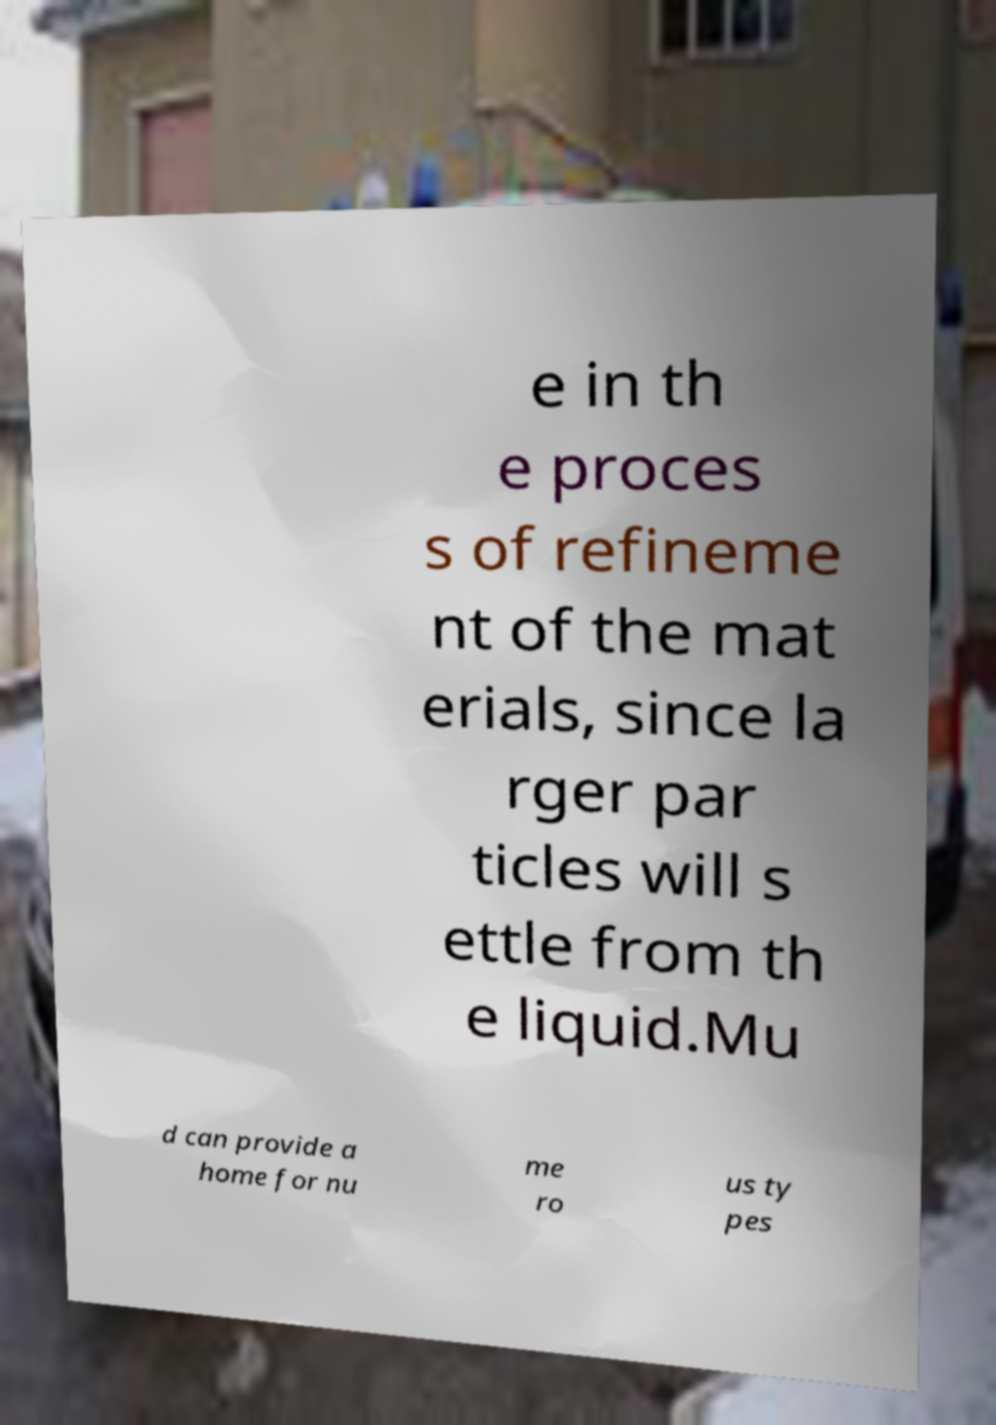Can you read and provide the text displayed in the image?This photo seems to have some interesting text. Can you extract and type it out for me? e in th e proces s of refineme nt of the mat erials, since la rger par ticles will s ettle from th e liquid.Mu d can provide a home for nu me ro us ty pes 